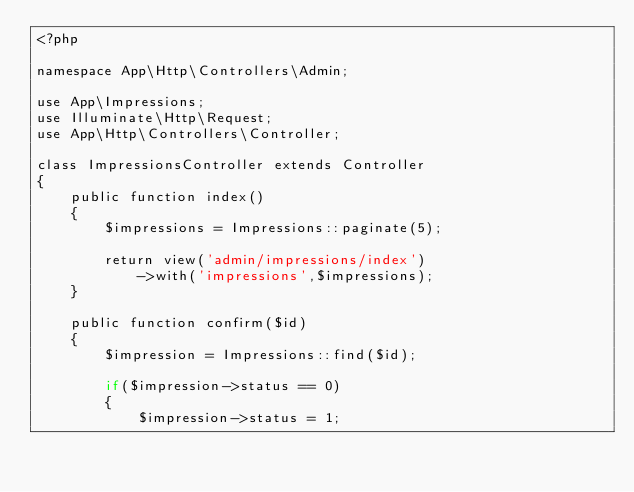<code> <loc_0><loc_0><loc_500><loc_500><_PHP_><?php

namespace App\Http\Controllers\Admin;

use App\Impressions;
use Illuminate\Http\Request;
use App\Http\Controllers\Controller;

class ImpressionsController extends Controller
{
    public function index()
    {
        $impressions = Impressions::paginate(5);

        return view('admin/impressions/index')
            ->with('impressions',$impressions);
    }

    public function confirm($id)
    {
        $impression = Impressions::find($id);

        if($impression->status == 0)
        {
            $impression->status = 1;</code> 